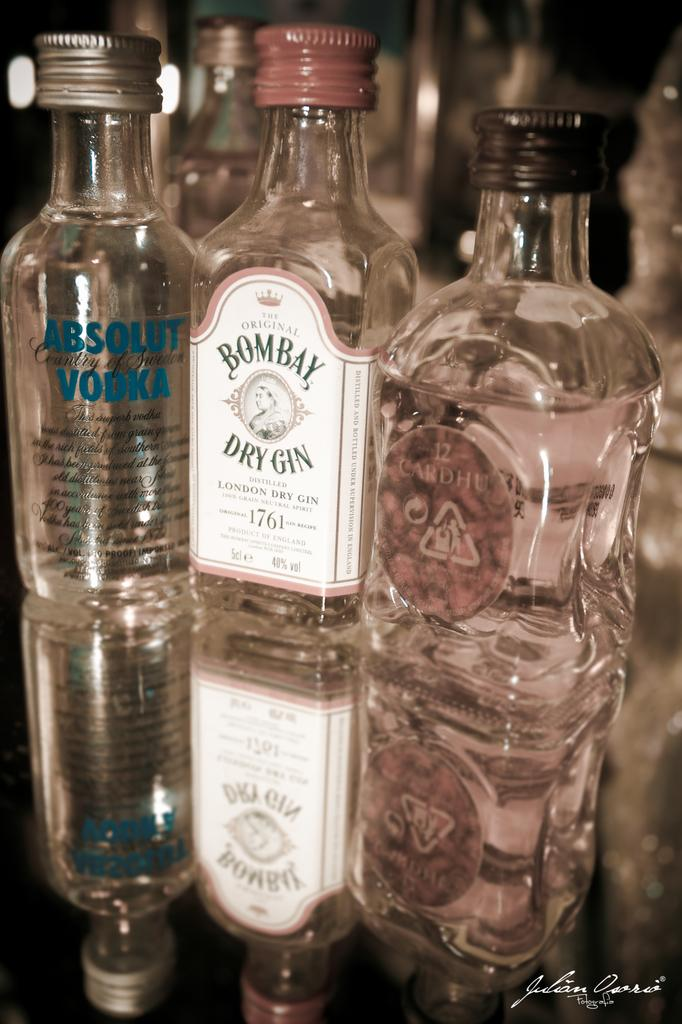<image>
Create a compact narrative representing the image presented. Three different alcohols featuring Bombay Dry Gin along with Absolut Vodka and Cardhe. 